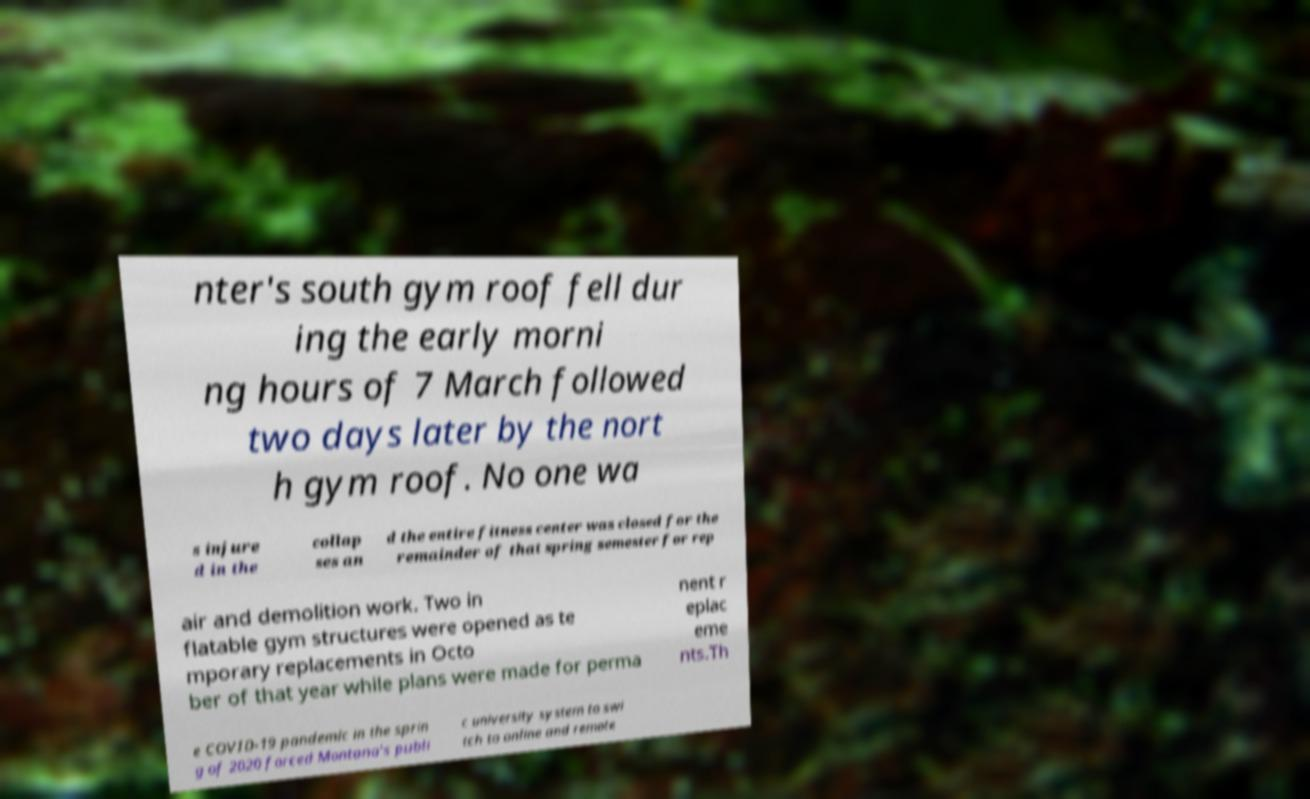Can you read and provide the text displayed in the image?This photo seems to have some interesting text. Can you extract and type it out for me? nter's south gym roof fell dur ing the early morni ng hours of 7 March followed two days later by the nort h gym roof. No one wa s injure d in the collap ses an d the entire fitness center was closed for the remainder of that spring semester for rep air and demolition work. Two in flatable gym structures were opened as te mporary replacements in Octo ber of that year while plans were made for perma nent r eplac eme nts.Th e COVID-19 pandemic in the sprin g of 2020 forced Montana's publi c university system to swi tch to online and remote 